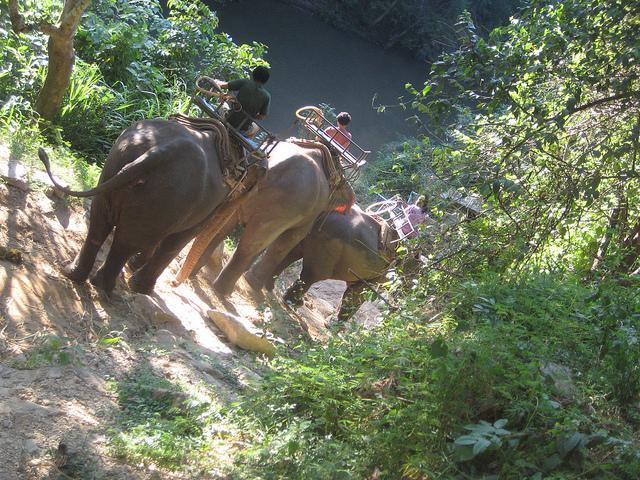How many elephants are visible?
Give a very brief answer. 3. How many elephants are there?
Give a very brief answer. 3. 